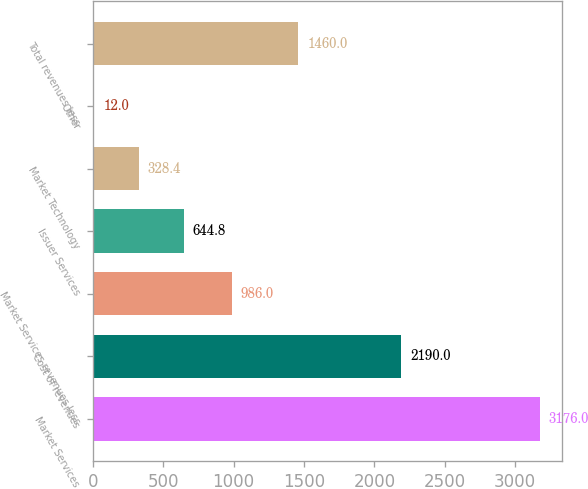Convert chart. <chart><loc_0><loc_0><loc_500><loc_500><bar_chart><fcel>Market Services<fcel>Cost of revenues<fcel>Market Services revenues less<fcel>Issuer Services<fcel>Market Technology<fcel>Other<fcel>Total revenues less<nl><fcel>3176<fcel>2190<fcel>986<fcel>644.8<fcel>328.4<fcel>12<fcel>1460<nl></chart> 